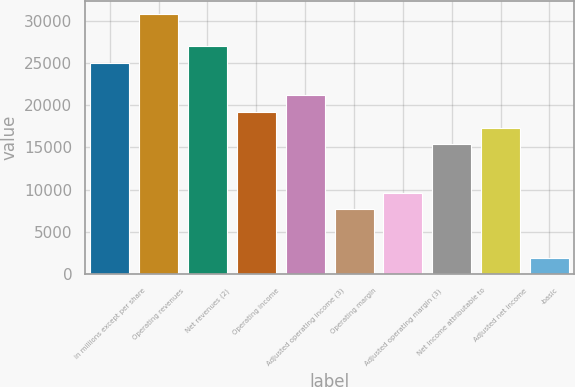Convert chart to OTSL. <chart><loc_0><loc_0><loc_500><loc_500><bar_chart><fcel>in millions except per share<fcel>Operating revenues<fcel>Net revenues (2)<fcel>Operating income<fcel>Adjusted operating income (3)<fcel>Operating margin<fcel>Adjusted operating margin (3)<fcel>Net income attributable to<fcel>Adjusted net income<fcel>-basic<nl><fcel>25033.6<fcel>30810.4<fcel>26959.2<fcel>19256.8<fcel>21182.4<fcel>7703.24<fcel>9628.83<fcel>15405.6<fcel>17331.2<fcel>1926.45<nl></chart> 